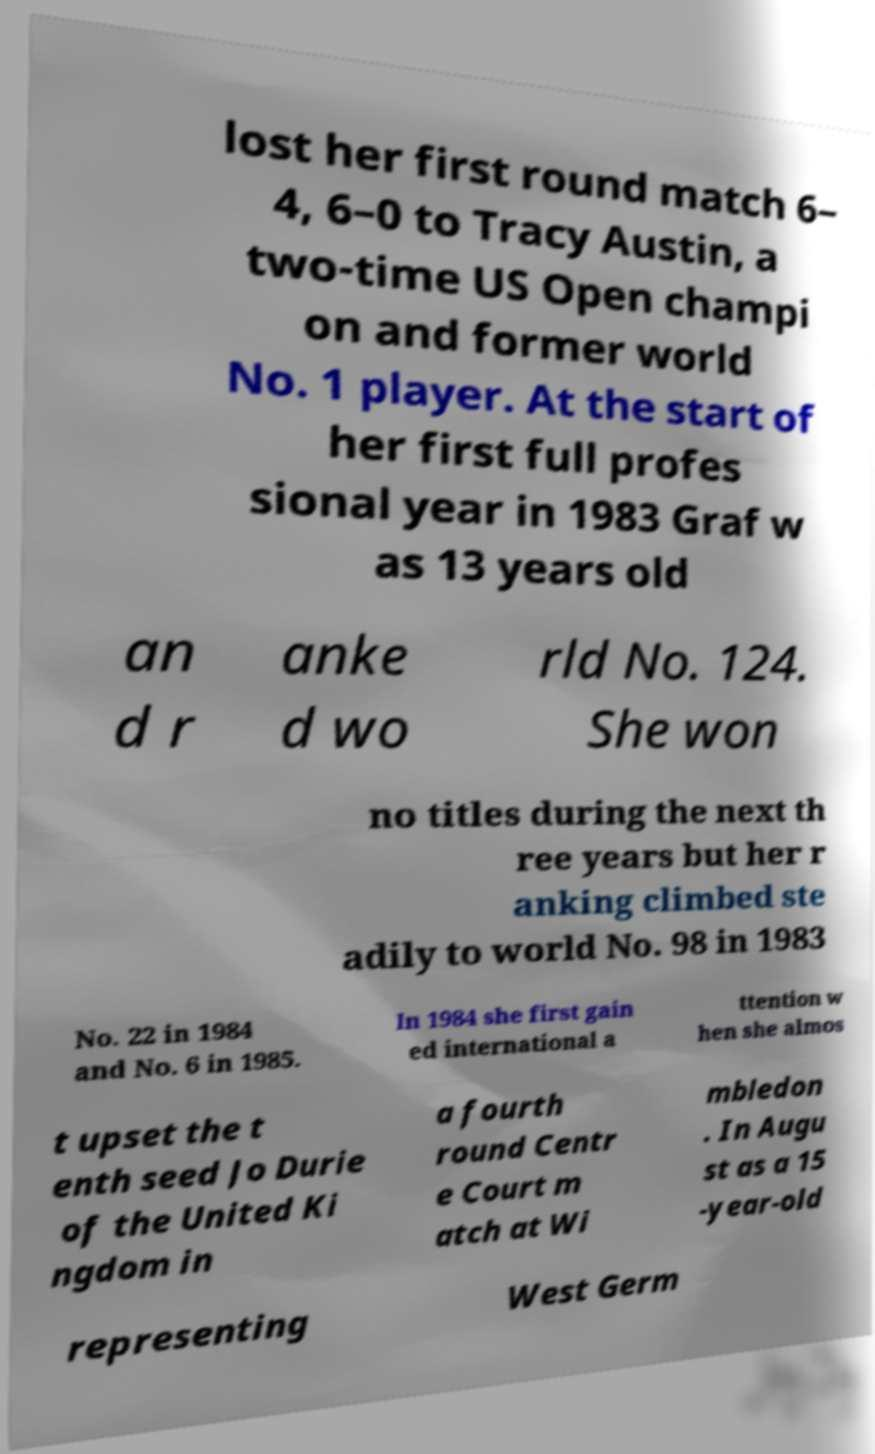Can you accurately transcribe the text from the provided image for me? lost her first round match 6– 4, 6–0 to Tracy Austin, a two-time US Open champi on and former world No. 1 player. At the start of her first full profes sional year in 1983 Graf w as 13 years old an d r anke d wo rld No. 124. She won no titles during the next th ree years but her r anking climbed ste adily to world No. 98 in 1983 No. 22 in 1984 and No. 6 in 1985. In 1984 she first gain ed international a ttention w hen she almos t upset the t enth seed Jo Durie of the United Ki ngdom in a fourth round Centr e Court m atch at Wi mbledon . In Augu st as a 15 -year-old representing West Germ 